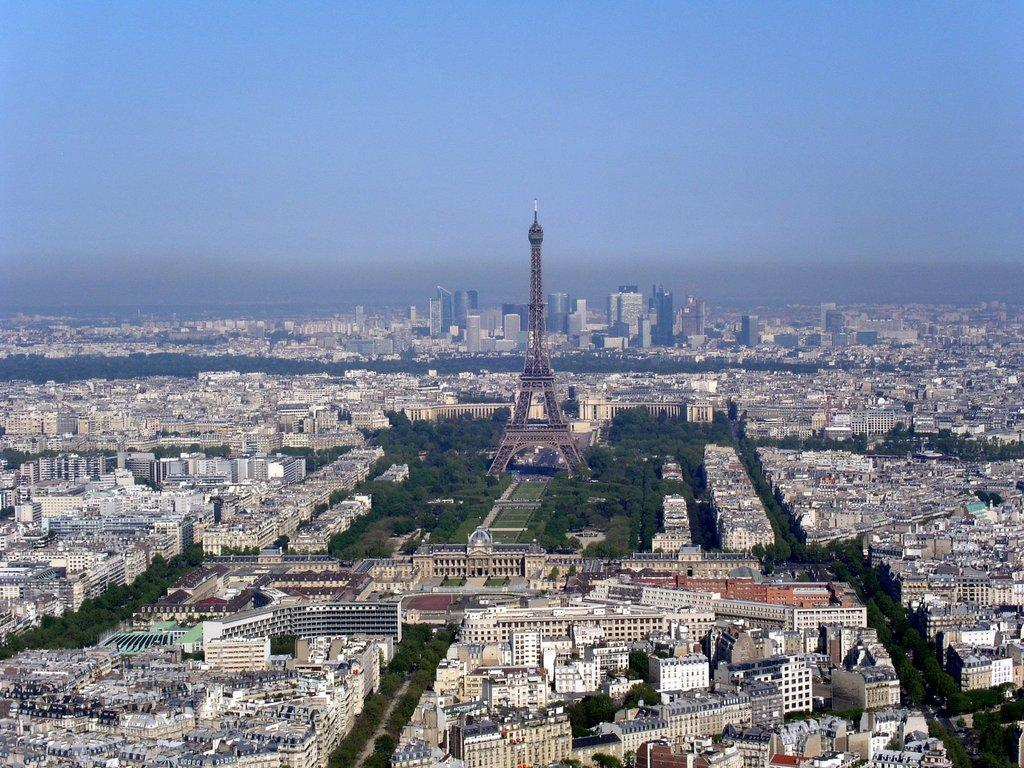What type of structures can be seen in the image? There are buildings and a tower in the image. What other natural elements are present in the image? There are trees in the image. What is the color of the sky in the image? The sky is blue and white in color. What type of star can be seen in the image? There is no star visible in the image. What type of relation exists between the buildings and the trees in the image? The provided facts do not give information about any relation between the buildings and the trees. 